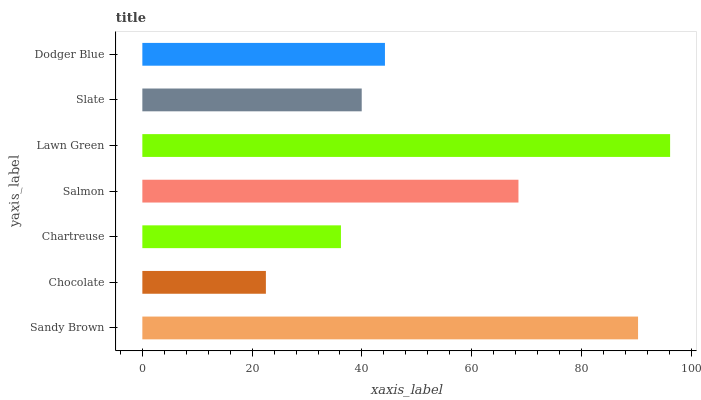Is Chocolate the minimum?
Answer yes or no. Yes. Is Lawn Green the maximum?
Answer yes or no. Yes. Is Chartreuse the minimum?
Answer yes or no. No. Is Chartreuse the maximum?
Answer yes or no. No. Is Chartreuse greater than Chocolate?
Answer yes or no. Yes. Is Chocolate less than Chartreuse?
Answer yes or no. Yes. Is Chocolate greater than Chartreuse?
Answer yes or no. No. Is Chartreuse less than Chocolate?
Answer yes or no. No. Is Dodger Blue the high median?
Answer yes or no. Yes. Is Dodger Blue the low median?
Answer yes or no. Yes. Is Lawn Green the high median?
Answer yes or no. No. Is Chocolate the low median?
Answer yes or no. No. 